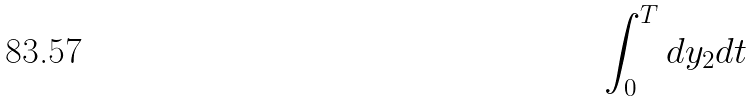Convert formula to latex. <formula><loc_0><loc_0><loc_500><loc_500>\int _ { 0 } ^ { T } d y _ { 2 } d t</formula> 